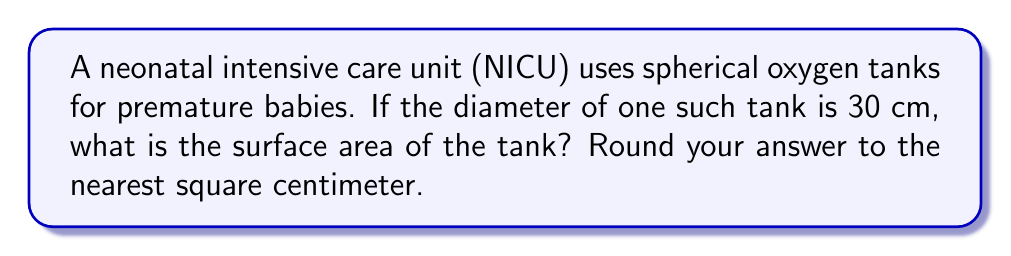Provide a solution to this math problem. To solve this problem, we'll follow these steps:

1) The formula for the surface area of a sphere is:
   $$A = 4\pi r^2$$
   where $A$ is the surface area and $r$ is the radius.

2) We're given the diameter, which is 30 cm. The radius is half of the diameter:
   $$r = \frac{30}{2} = 15 \text{ cm}$$

3) Now we can substitute this into our formula:
   $$A = 4\pi (15 \text{ cm})^2$$

4) Simplify:
   $$A = 4\pi (225 \text{ cm}^2)$$
   $$A = 900\pi \text{ cm}^2$$

5) Calculate (using $\pi \approx 3.14159$):
   $$A \approx 900 \times 3.14159 \text{ cm}^2$$
   $$A \approx 2827.431 \text{ cm}^2$$

6) Rounding to the nearest square centimeter:
   $$A \approx 2827 \text{ cm}^2$$

This surface area represents the total external area of the oxygen tank, which is crucial for heat exchange and storage considerations in the NICU environment.
Answer: 2827 cm² 